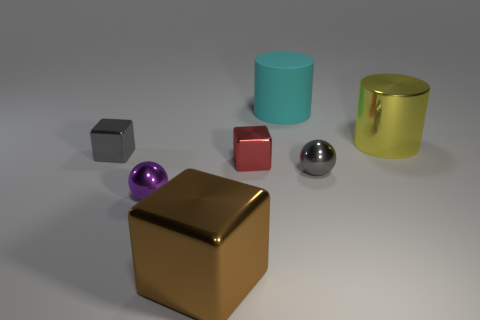Is there a green sphere of the same size as the gray sphere?
Provide a succinct answer. No. There is a cylinder to the right of the large cyan rubber cylinder; what is its size?
Offer a terse response. Large. What size is the yellow thing?
Your answer should be very brief. Large. How many cylinders are either metal objects or big brown metallic things?
Your answer should be very brief. 1. What is the size of the yellow cylinder that is the same material as the brown block?
Your answer should be compact. Large. There is a rubber object; are there any spheres left of it?
Provide a short and direct response. Yes. Do the large matte object and the big metallic thing that is behind the purple sphere have the same shape?
Offer a very short reply. Yes. How many objects are either gray things in front of the tiny gray metal cube or large brown things?
Offer a terse response. 2. Is there any other thing that is made of the same material as the cyan thing?
Your response must be concise. No. How many tiny gray objects are on the left side of the red block and on the right side of the purple sphere?
Offer a terse response. 0. 